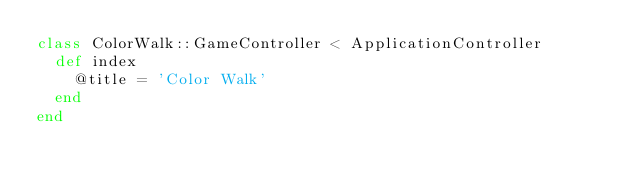Convert code to text. <code><loc_0><loc_0><loc_500><loc_500><_Ruby_>class ColorWalk::GameController < ApplicationController
  def index
    @title = 'Color Walk'
  end
end
</code> 